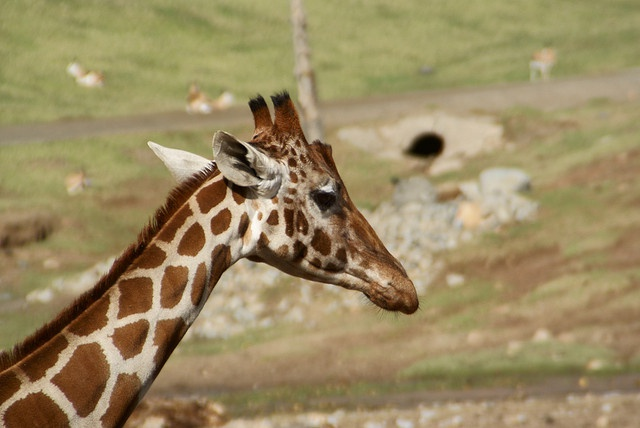Describe the objects in this image and their specific colors. I can see a giraffe in olive, maroon, black, and tan tones in this image. 